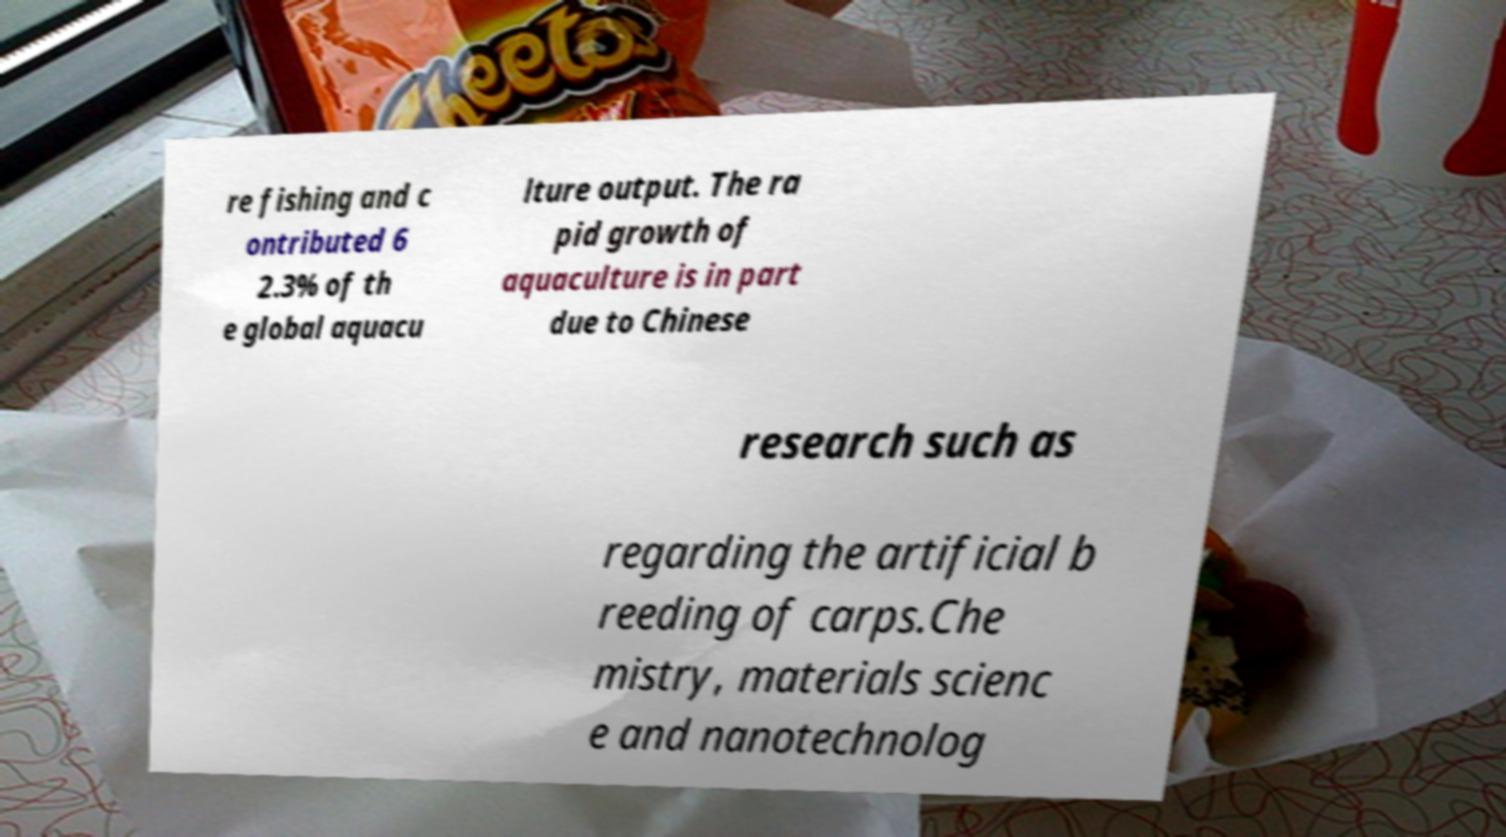What messages or text are displayed in this image? I need them in a readable, typed format. re fishing and c ontributed 6 2.3% of th e global aquacu lture output. The ra pid growth of aquaculture is in part due to Chinese research such as regarding the artificial b reeding of carps.Che mistry, materials scienc e and nanotechnolog 